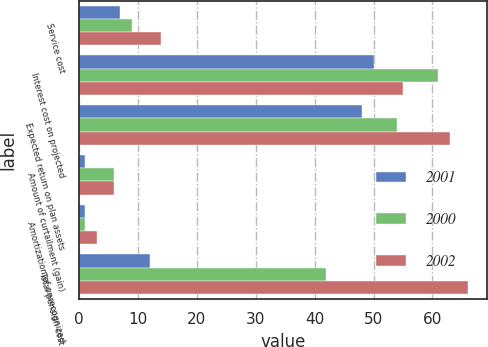Convert chart to OTSL. <chart><loc_0><loc_0><loc_500><loc_500><stacked_bar_chart><ecel><fcel>Service cost<fcel>Interest cost on projected<fcel>Expected return on plan assets<fcel>Amount of curtailment (gain)<fcel>Amortization of unrecognized<fcel>Total pension cost<nl><fcel>2001<fcel>7<fcel>50<fcel>48<fcel>1<fcel>1<fcel>12<nl><fcel>2000<fcel>9<fcel>61<fcel>54<fcel>6<fcel>1<fcel>42<nl><fcel>2002<fcel>14<fcel>55<fcel>63<fcel>6<fcel>3<fcel>66<nl></chart> 